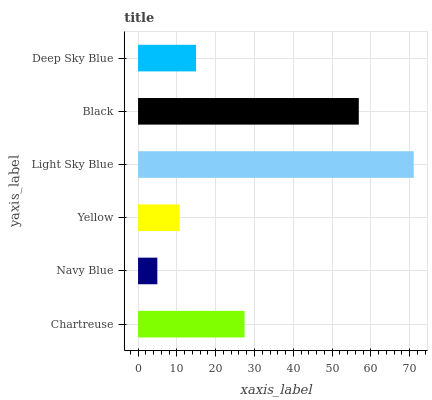Is Navy Blue the minimum?
Answer yes or no. Yes. Is Light Sky Blue the maximum?
Answer yes or no. Yes. Is Yellow the minimum?
Answer yes or no. No. Is Yellow the maximum?
Answer yes or no. No. Is Yellow greater than Navy Blue?
Answer yes or no. Yes. Is Navy Blue less than Yellow?
Answer yes or no. Yes. Is Navy Blue greater than Yellow?
Answer yes or no. No. Is Yellow less than Navy Blue?
Answer yes or no. No. Is Chartreuse the high median?
Answer yes or no. Yes. Is Deep Sky Blue the low median?
Answer yes or no. Yes. Is Black the high median?
Answer yes or no. No. Is Yellow the low median?
Answer yes or no. No. 